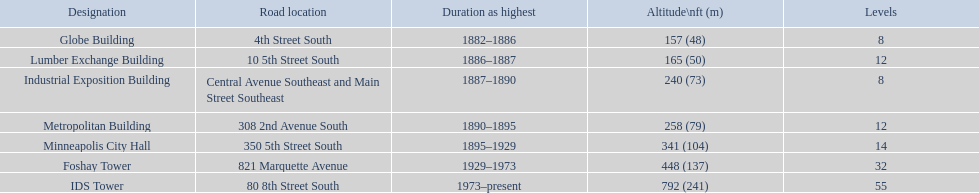What are the tallest buildings in minneapolis? Globe Building, Lumber Exchange Building, Industrial Exposition Building, Metropolitan Building, Minneapolis City Hall, Foshay Tower, IDS Tower. What is the height of the metropolitan building? 258 (79). What is the height of the lumber exchange building? 165 (50). Of those two which is taller? Metropolitan Building. 